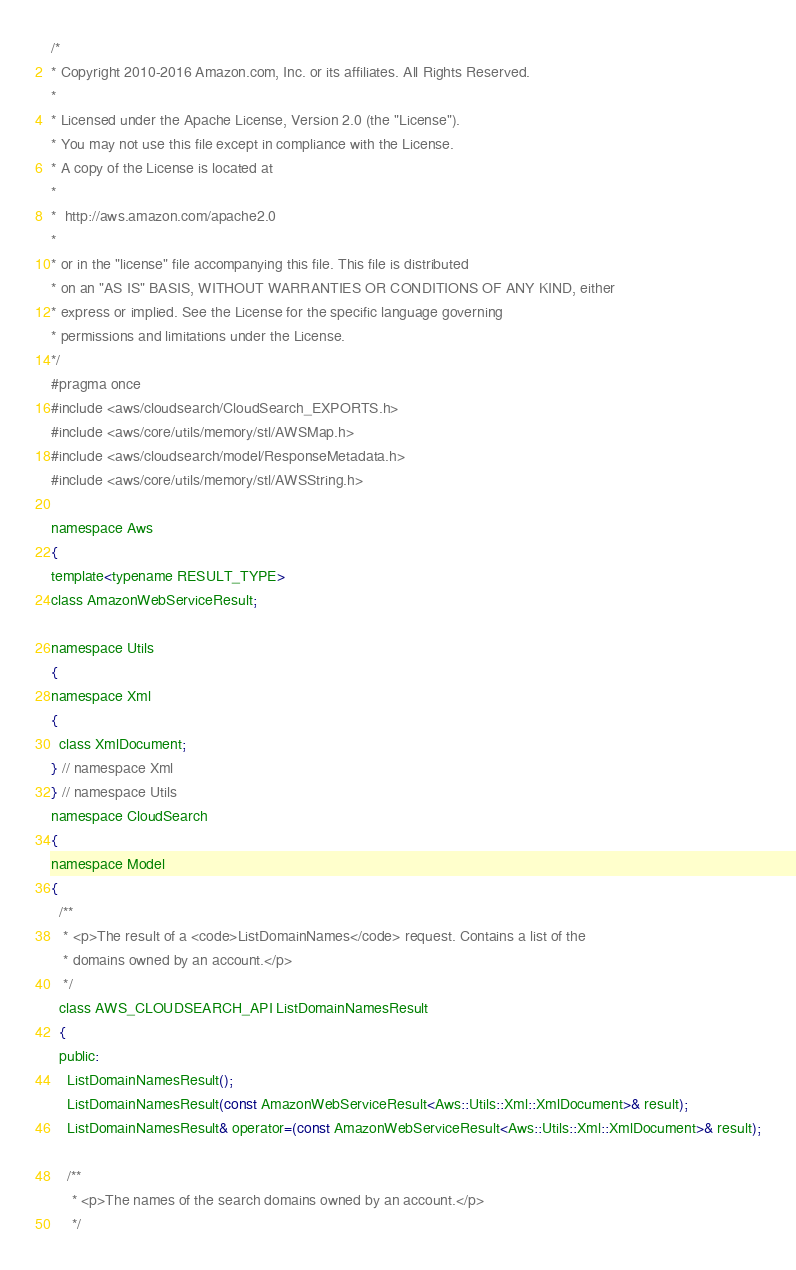<code> <loc_0><loc_0><loc_500><loc_500><_C_>/*
* Copyright 2010-2016 Amazon.com, Inc. or its affiliates. All Rights Reserved.
*
* Licensed under the Apache License, Version 2.0 (the "License").
* You may not use this file except in compliance with the License.
* A copy of the License is located at
*
*  http://aws.amazon.com/apache2.0
*
* or in the "license" file accompanying this file. This file is distributed
* on an "AS IS" BASIS, WITHOUT WARRANTIES OR CONDITIONS OF ANY KIND, either
* express or implied. See the License for the specific language governing
* permissions and limitations under the License.
*/
#pragma once
#include <aws/cloudsearch/CloudSearch_EXPORTS.h>
#include <aws/core/utils/memory/stl/AWSMap.h>
#include <aws/cloudsearch/model/ResponseMetadata.h>
#include <aws/core/utils/memory/stl/AWSString.h>

namespace Aws
{
template<typename RESULT_TYPE>
class AmazonWebServiceResult;

namespace Utils
{
namespace Xml
{
  class XmlDocument;
} // namespace Xml
} // namespace Utils
namespace CloudSearch
{
namespace Model
{
  /**
   * <p>The result of a <code>ListDomainNames</code> request. Contains a list of the
   * domains owned by an account.</p>
   */
  class AWS_CLOUDSEARCH_API ListDomainNamesResult
  {
  public:
    ListDomainNamesResult();
    ListDomainNamesResult(const AmazonWebServiceResult<Aws::Utils::Xml::XmlDocument>& result);
    ListDomainNamesResult& operator=(const AmazonWebServiceResult<Aws::Utils::Xml::XmlDocument>& result);

    /**
     * <p>The names of the search domains owned by an account.</p>
     */</code> 